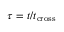Convert formula to latex. <formula><loc_0><loc_0><loc_500><loc_500>\tau = t / t _ { c r o s s }</formula> 